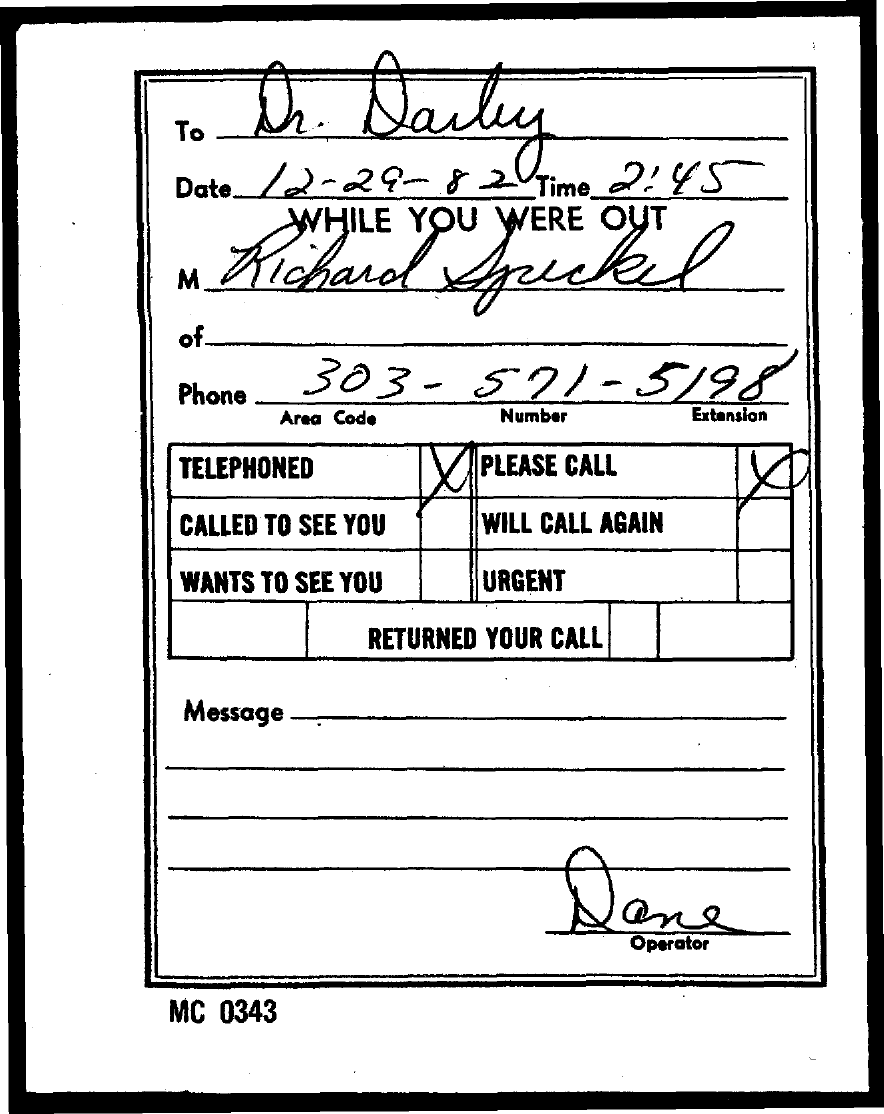What is the date mentioned in the document?
Your answer should be very brief. 12-29-82. What is the time mentioned in the document?
Your answer should be very brief. 2:45. What is the area code?
Keep it short and to the point. 303. 